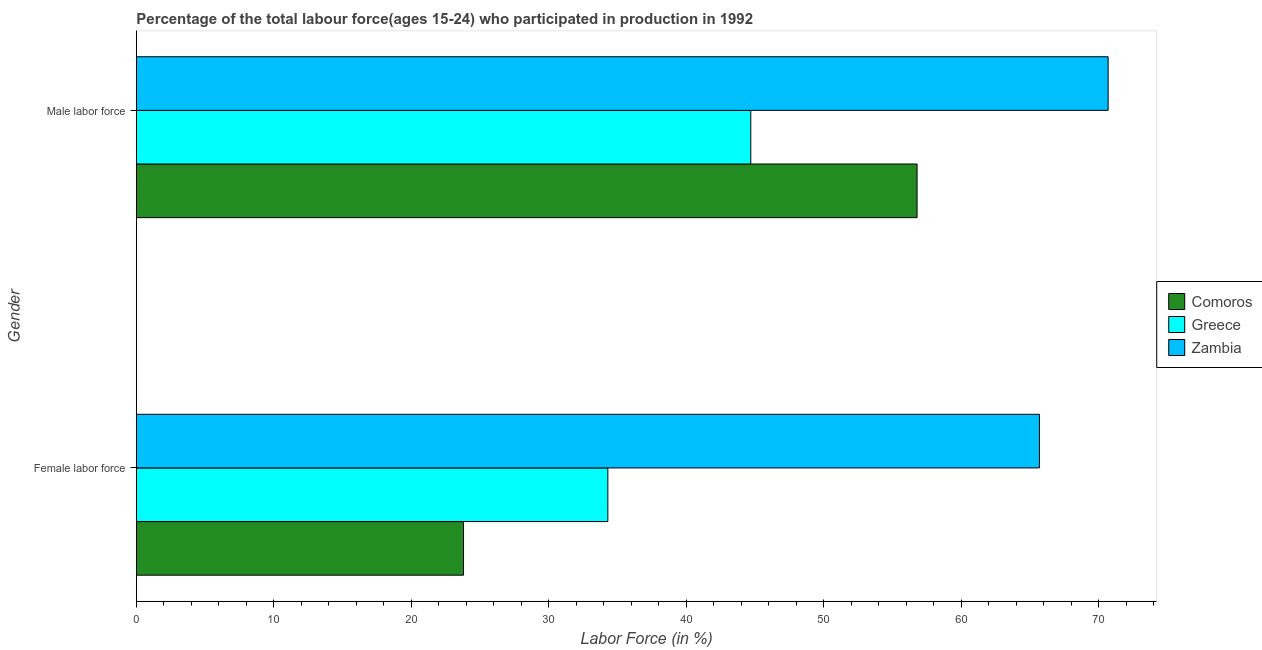How many different coloured bars are there?
Make the answer very short. 3. Are the number of bars on each tick of the Y-axis equal?
Provide a short and direct response. Yes. How many bars are there on the 2nd tick from the top?
Offer a terse response. 3. How many bars are there on the 2nd tick from the bottom?
Ensure brevity in your answer.  3. What is the label of the 2nd group of bars from the top?
Make the answer very short. Female labor force. What is the percentage of male labour force in Comoros?
Make the answer very short. 56.8. Across all countries, what is the maximum percentage of female labor force?
Ensure brevity in your answer.  65.7. Across all countries, what is the minimum percentage of male labour force?
Provide a short and direct response. 44.7. In which country was the percentage of male labour force maximum?
Offer a terse response. Zambia. In which country was the percentage of female labor force minimum?
Offer a terse response. Comoros. What is the total percentage of male labour force in the graph?
Provide a succinct answer. 172.2. What is the difference between the percentage of female labor force in Comoros and that in Greece?
Ensure brevity in your answer.  -10.5. What is the difference between the percentage of female labor force in Zambia and the percentage of male labour force in Comoros?
Give a very brief answer. 8.9. What is the average percentage of female labor force per country?
Provide a short and direct response. 41.27. What is the difference between the percentage of male labour force and percentage of female labor force in Greece?
Provide a succinct answer. 10.4. What is the ratio of the percentage of male labour force in Greece to that in Zambia?
Your answer should be compact. 0.63. In how many countries, is the percentage of female labor force greater than the average percentage of female labor force taken over all countries?
Give a very brief answer. 1. What does the 3rd bar from the bottom in Female labor force represents?
Make the answer very short. Zambia. How many bars are there?
Your answer should be very brief. 6. How many legend labels are there?
Provide a short and direct response. 3. What is the title of the graph?
Your response must be concise. Percentage of the total labour force(ages 15-24) who participated in production in 1992. What is the label or title of the X-axis?
Offer a very short reply. Labor Force (in %). What is the label or title of the Y-axis?
Your answer should be compact. Gender. What is the Labor Force (in %) of Comoros in Female labor force?
Your response must be concise. 23.8. What is the Labor Force (in %) of Greece in Female labor force?
Offer a terse response. 34.3. What is the Labor Force (in %) in Zambia in Female labor force?
Provide a short and direct response. 65.7. What is the Labor Force (in %) of Comoros in Male labor force?
Provide a short and direct response. 56.8. What is the Labor Force (in %) in Greece in Male labor force?
Provide a succinct answer. 44.7. What is the Labor Force (in %) in Zambia in Male labor force?
Provide a succinct answer. 70.7. Across all Gender, what is the maximum Labor Force (in %) in Comoros?
Make the answer very short. 56.8. Across all Gender, what is the maximum Labor Force (in %) in Greece?
Provide a succinct answer. 44.7. Across all Gender, what is the maximum Labor Force (in %) in Zambia?
Make the answer very short. 70.7. Across all Gender, what is the minimum Labor Force (in %) in Comoros?
Your response must be concise. 23.8. Across all Gender, what is the minimum Labor Force (in %) in Greece?
Give a very brief answer. 34.3. Across all Gender, what is the minimum Labor Force (in %) in Zambia?
Make the answer very short. 65.7. What is the total Labor Force (in %) of Comoros in the graph?
Provide a succinct answer. 80.6. What is the total Labor Force (in %) in Greece in the graph?
Ensure brevity in your answer.  79. What is the total Labor Force (in %) of Zambia in the graph?
Provide a succinct answer. 136.4. What is the difference between the Labor Force (in %) of Comoros in Female labor force and that in Male labor force?
Ensure brevity in your answer.  -33. What is the difference between the Labor Force (in %) of Zambia in Female labor force and that in Male labor force?
Make the answer very short. -5. What is the difference between the Labor Force (in %) in Comoros in Female labor force and the Labor Force (in %) in Greece in Male labor force?
Ensure brevity in your answer.  -20.9. What is the difference between the Labor Force (in %) in Comoros in Female labor force and the Labor Force (in %) in Zambia in Male labor force?
Your response must be concise. -46.9. What is the difference between the Labor Force (in %) in Greece in Female labor force and the Labor Force (in %) in Zambia in Male labor force?
Give a very brief answer. -36.4. What is the average Labor Force (in %) of Comoros per Gender?
Provide a succinct answer. 40.3. What is the average Labor Force (in %) of Greece per Gender?
Your answer should be compact. 39.5. What is the average Labor Force (in %) of Zambia per Gender?
Your answer should be very brief. 68.2. What is the difference between the Labor Force (in %) in Comoros and Labor Force (in %) in Zambia in Female labor force?
Your answer should be compact. -41.9. What is the difference between the Labor Force (in %) in Greece and Labor Force (in %) in Zambia in Female labor force?
Offer a very short reply. -31.4. What is the difference between the Labor Force (in %) in Comoros and Labor Force (in %) in Zambia in Male labor force?
Give a very brief answer. -13.9. What is the difference between the Labor Force (in %) in Greece and Labor Force (in %) in Zambia in Male labor force?
Your response must be concise. -26. What is the ratio of the Labor Force (in %) of Comoros in Female labor force to that in Male labor force?
Offer a terse response. 0.42. What is the ratio of the Labor Force (in %) of Greece in Female labor force to that in Male labor force?
Your response must be concise. 0.77. What is the ratio of the Labor Force (in %) of Zambia in Female labor force to that in Male labor force?
Make the answer very short. 0.93. What is the difference between the highest and the second highest Labor Force (in %) of Comoros?
Offer a very short reply. 33. What is the difference between the highest and the lowest Labor Force (in %) in Comoros?
Make the answer very short. 33. What is the difference between the highest and the lowest Labor Force (in %) of Greece?
Keep it short and to the point. 10.4. What is the difference between the highest and the lowest Labor Force (in %) of Zambia?
Provide a succinct answer. 5. 